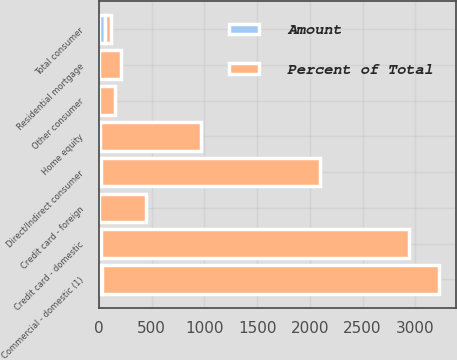Convert chart. <chart><loc_0><loc_0><loc_500><loc_500><stacked_bar_chart><ecel><fcel>Residential mortgage<fcel>Credit card - domestic<fcel>Credit card - foreign<fcel>Home equity<fcel>Direct/Indirect consumer<fcel>Other consumer<fcel>Total consumer<fcel>Commercial - domestic (1)<nl><fcel>Percent of Total<fcel>207<fcel>2919<fcel>441<fcel>963<fcel>2077<fcel>151<fcel>58.3<fcel>3194<nl><fcel>Amount<fcel>1.8<fcel>25.2<fcel>3.8<fcel>8.3<fcel>17.9<fcel>1.3<fcel>58.3<fcel>27.6<nl></chart> 